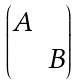Convert formula to latex. <formula><loc_0><loc_0><loc_500><loc_500>\begin{pmatrix} A \\ & B \end{pmatrix}</formula> 